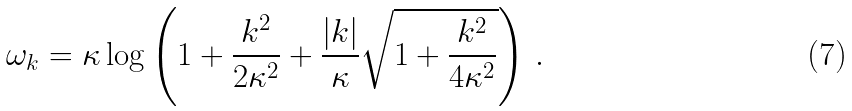<formula> <loc_0><loc_0><loc_500><loc_500>\omega _ { k } = \kappa \log \left ( 1 + \frac { { k } ^ { 2 } } { 2 \kappa ^ { 2 } } + \frac { | { k } | } { \kappa } \sqrt { 1 + \frac { k ^ { 2 } } { 4 \kappa ^ { 2 } } } \right ) \, .</formula> 